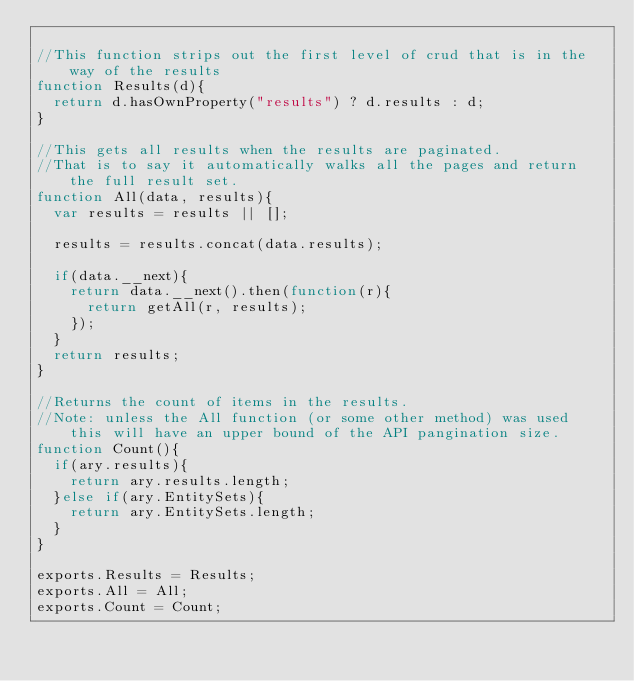<code> <loc_0><loc_0><loc_500><loc_500><_JavaScript_>
//This function strips out the first level of crud that is in the way of the results
function Results(d){ 
	return d.hasOwnProperty("results") ? d.results : d; 
}

//This gets all results when the results are paginated.
//That is to say it automatically walks all the pages and return the full result set.
function All(data, results){
	var results = results || [];
	
	results = results.concat(data.results);
	
	if(data.__next){
		return data.__next().then(function(r){
			return getAll(r, results);
		});
	}
	return results;
}

//Returns the count of items in the results.
//Note: unless the All function (or some other method) was used this will have an upper bound of the API pangination size.
function Count(){
	if(ary.results){
		return ary.results.length;
	}else if(ary.EntitySets){
		return ary.EntitySets.length;
	}
}

exports.Results = Results;
exports.All = All;
exports.Count = Count;

</code> 